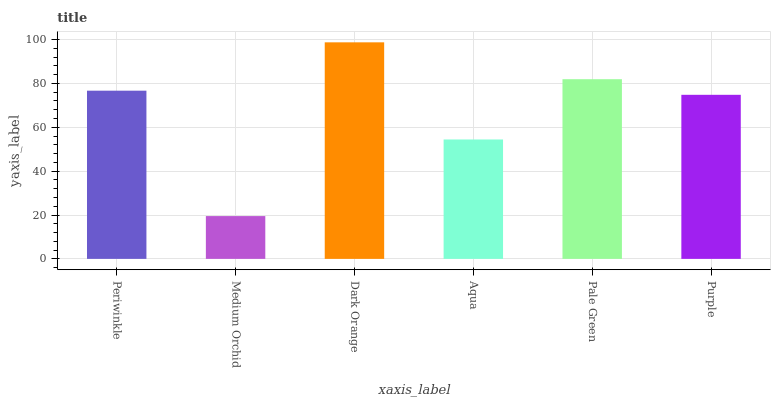Is Medium Orchid the minimum?
Answer yes or no. Yes. Is Dark Orange the maximum?
Answer yes or no. Yes. Is Dark Orange the minimum?
Answer yes or no. No. Is Medium Orchid the maximum?
Answer yes or no. No. Is Dark Orange greater than Medium Orchid?
Answer yes or no. Yes. Is Medium Orchid less than Dark Orange?
Answer yes or no. Yes. Is Medium Orchid greater than Dark Orange?
Answer yes or no. No. Is Dark Orange less than Medium Orchid?
Answer yes or no. No. Is Periwinkle the high median?
Answer yes or no. Yes. Is Purple the low median?
Answer yes or no. Yes. Is Dark Orange the high median?
Answer yes or no. No. Is Aqua the low median?
Answer yes or no. No. 